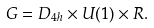<formula> <loc_0><loc_0><loc_500><loc_500>G = D _ { 4 h } \times U ( 1 ) \times R .</formula> 